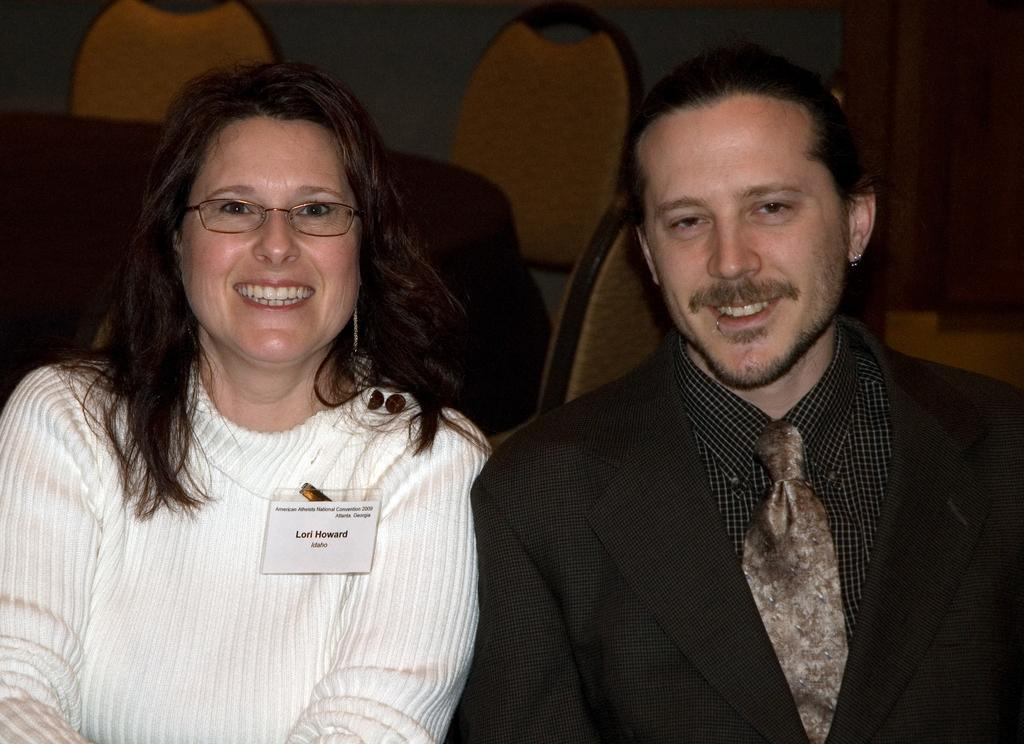What are the genders of the people in the image? There is a man and a woman in the image. What is the woman wearing on her face? The woman is wearing glasses (specs) in the image. What is the woman wearing on her clothing? The woman is wearing a badge in the image. What can be seen in the background of the image? There are chairs in the background of the image. Can you see a whip being used by the man in the image? No, there is no whip present in the image. What type of toad is sitting on the woman's shoulder in the image? There is no toad present in the image. 